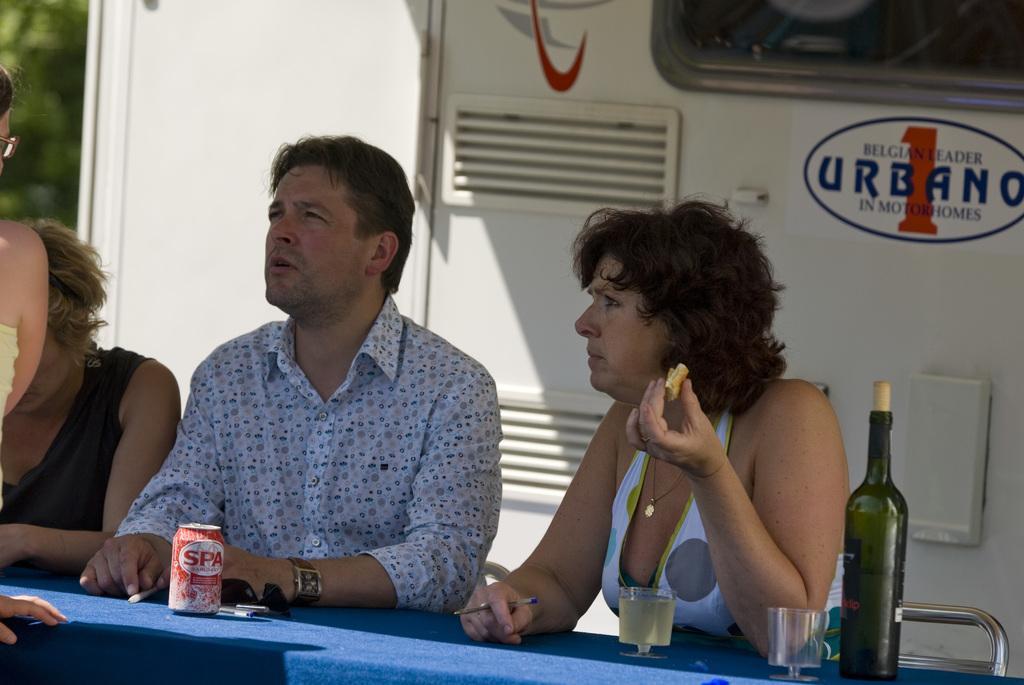Can you describe this image briefly? As we can see in the image there are three people sitting on chairs and a table. On table there is a bottle, glasses and tin. 